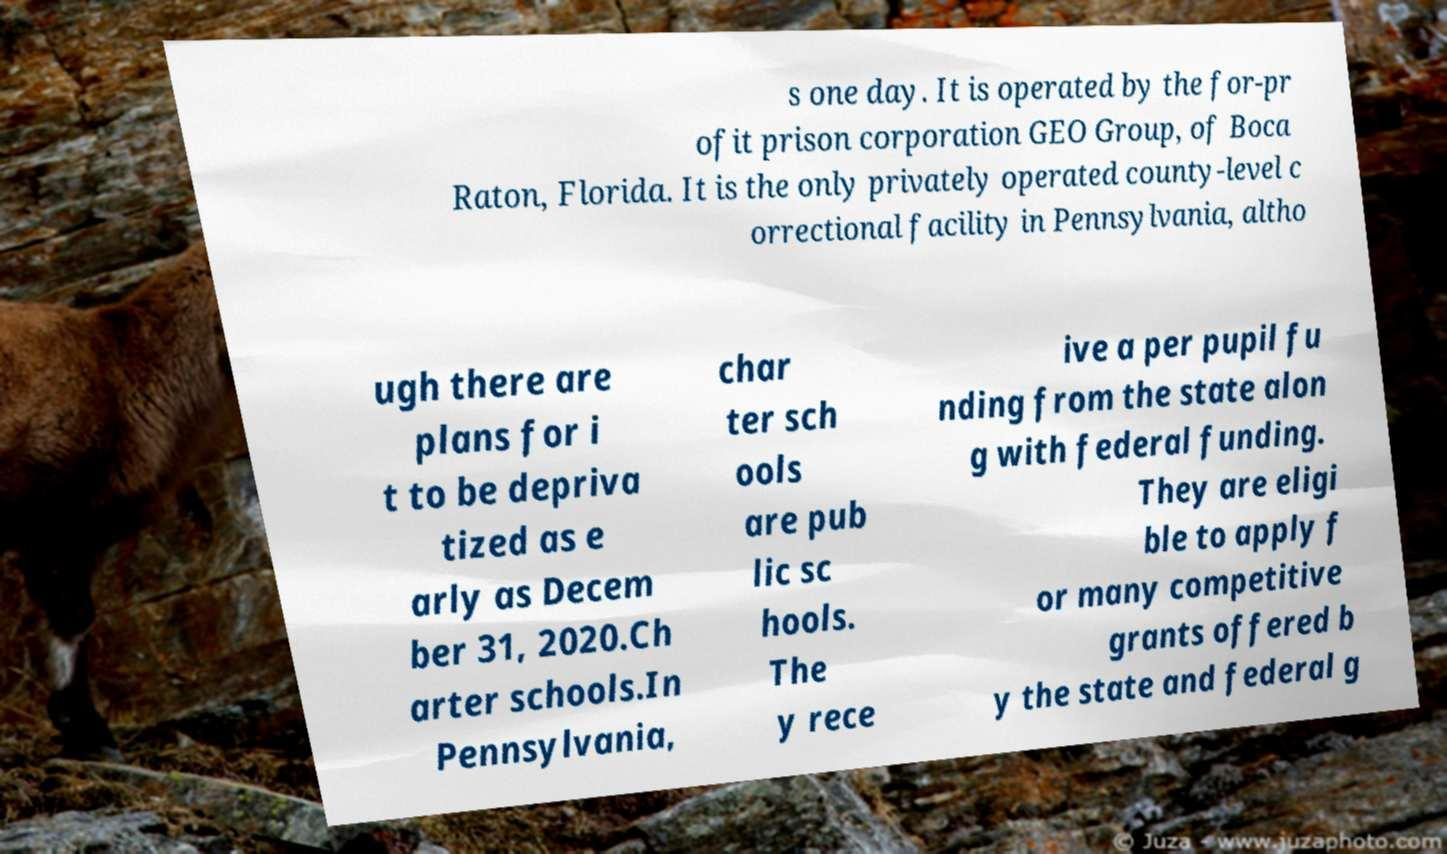Please read and relay the text visible in this image. What does it say? s one day. It is operated by the for-pr ofit prison corporation GEO Group, of Boca Raton, Florida. It is the only privately operated county-level c orrectional facility in Pennsylvania, altho ugh there are plans for i t to be depriva tized as e arly as Decem ber 31, 2020.Ch arter schools.In Pennsylvania, char ter sch ools are pub lic sc hools. The y rece ive a per pupil fu nding from the state alon g with federal funding. They are eligi ble to apply f or many competitive grants offered b y the state and federal g 